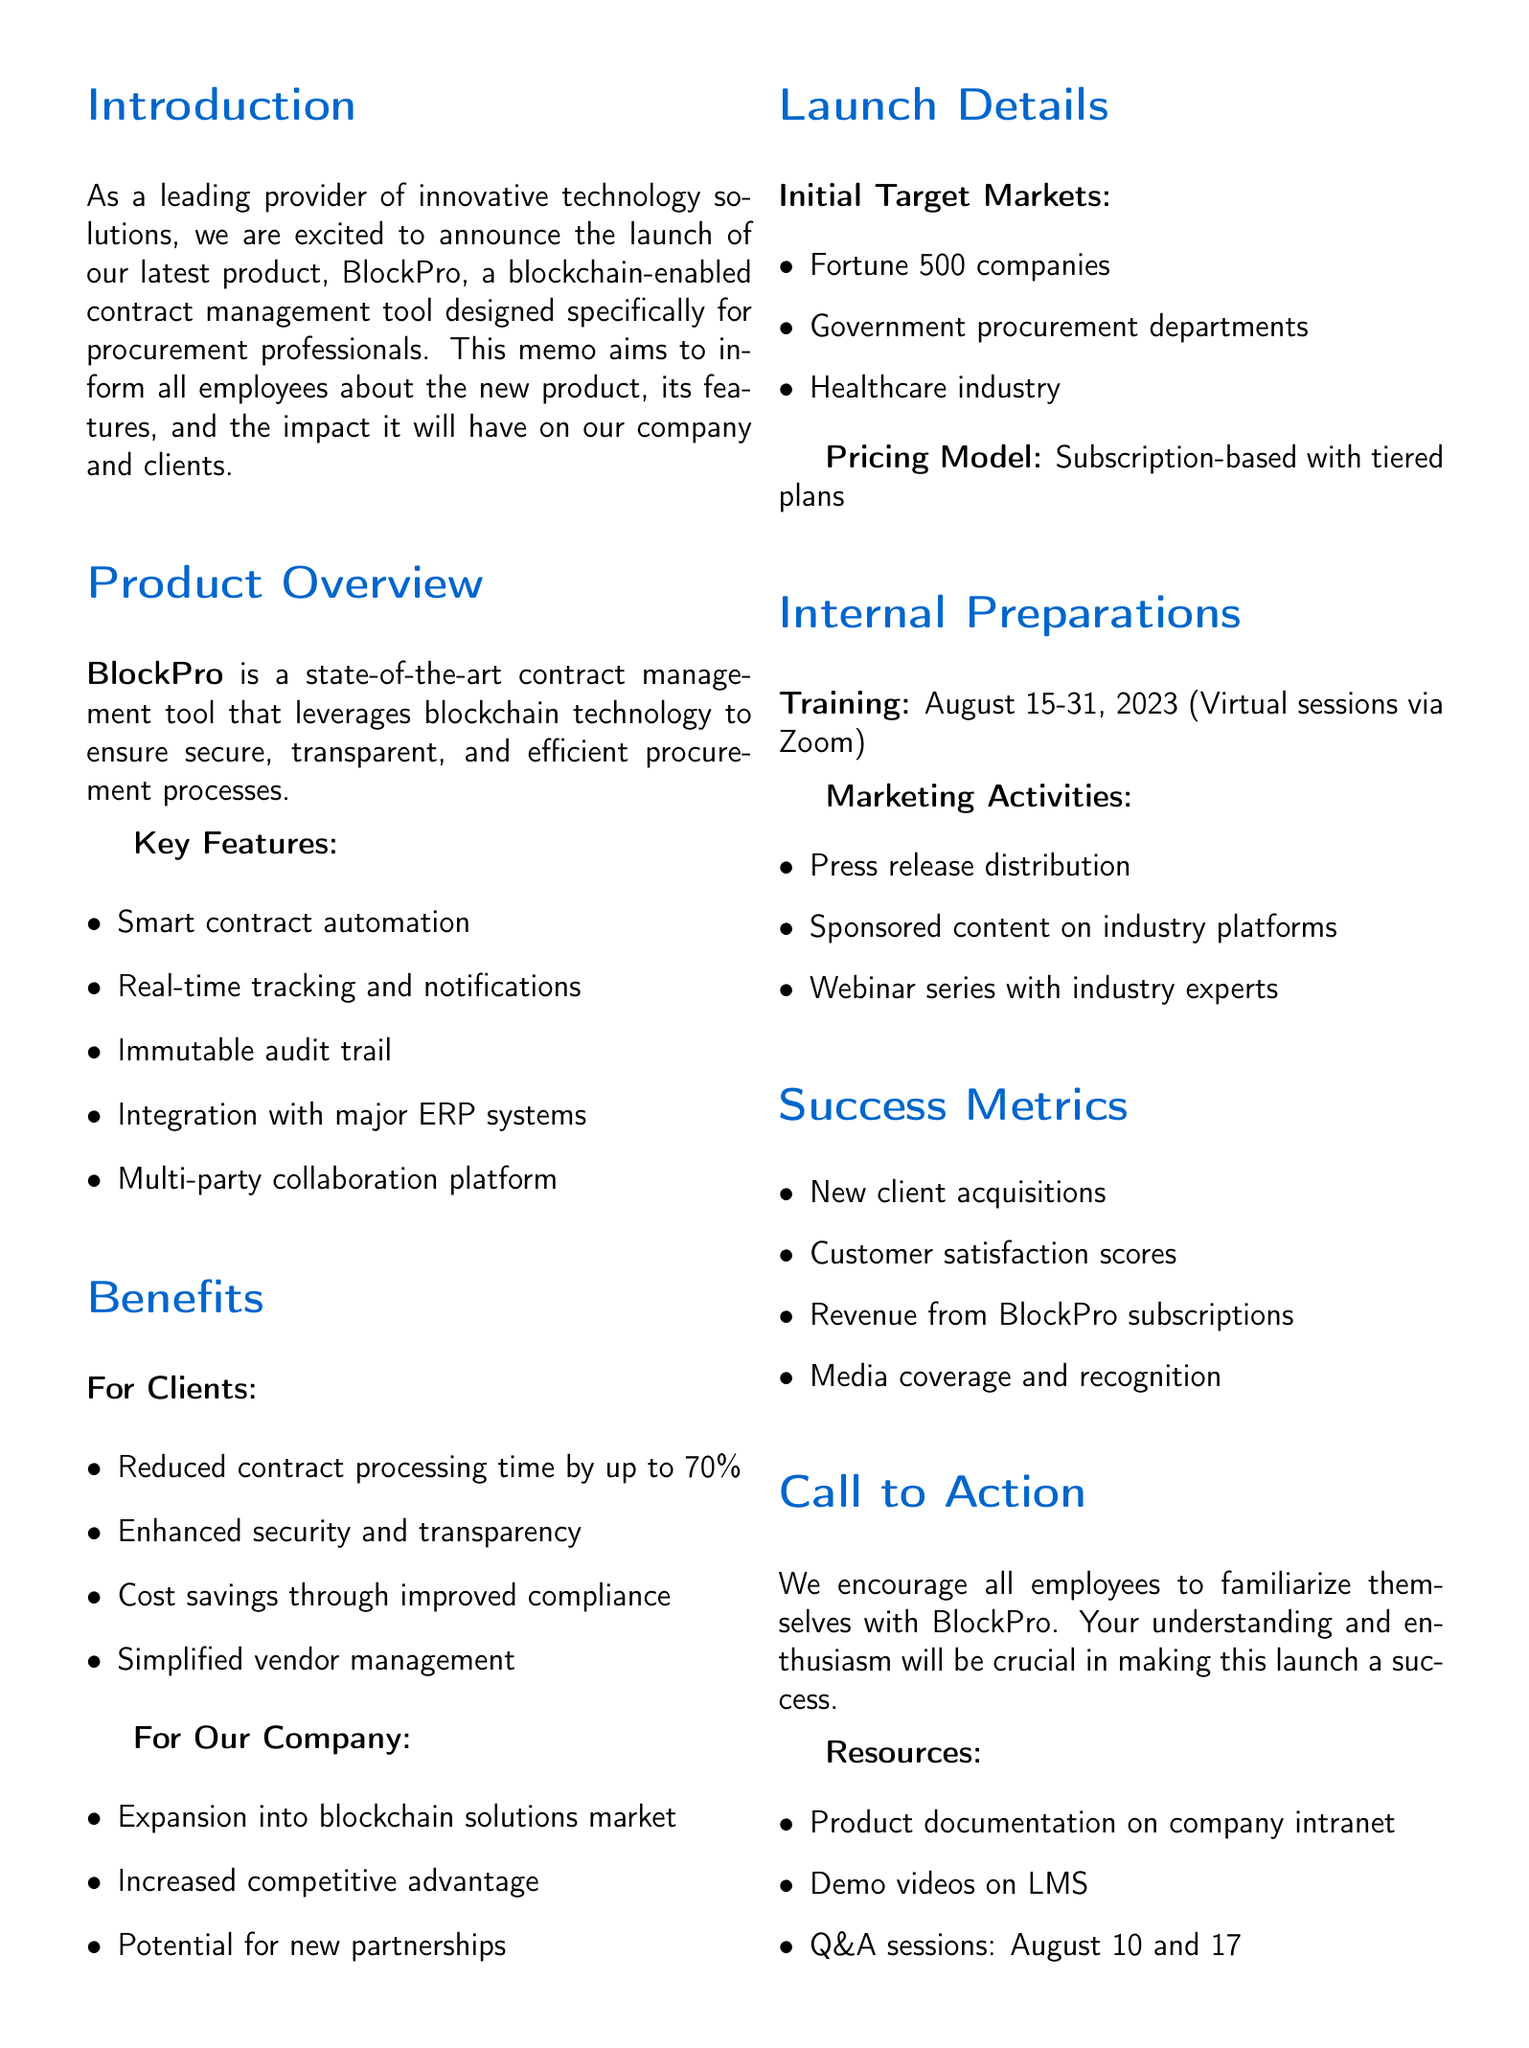What is the name of the new tool? The document explicitly introduces the tool as BlockPro, which is its name.
Answer: BlockPro What is the launch date of BlockPro? The memo states the specific launch date of the product, which is September 1, 2023.
Answer: September 1, 2023 What are the initial target markets for BlockPro? The document lists three initial target markets for BlockPro: Fortune 500 companies, government procurement departments, and the healthcare industry.
Answer: Fortune 500 companies, government procurement departments, healthcare industry What is the expected reduction in contract processing time for clients? The memo mentions that clients can expect a reduction in contract processing time by up to 70%.
Answer: 70% What are the key training dates for internal preparations? The document notes that training sessions for employees are scheduled from August 15 to August 31, 2023.
Answer: August 15-31, 2023 What type of pricing model does BlockPro use? The memo describes the pricing model as subscription-based with tiered plans tailored to organization size and needs.
Answer: Subscription-based with tiered plans What are the success metrics defined in the document? The memo lists multiple success metrics including new client acquisitions and customer satisfaction scores.
Answer: Number of new client acquisitions, customer satisfaction scores, revenue generated from BlockPro subscriptions, media coverage and industry recognition Who should employees contact for questions regarding BlockPro? The memo provides a contact email for employees to reach out to the BlockPro Launch Team for any questions or suggestions.
Answer: blockpro@ourcompany.com What is the main purpose of this memo? The memo mentions its specific purpose is to inform all employees about the new product, its features, and the impact it will have on the company and clients.
Answer: To inform all employees about the new product, its features, and the impact it will have on our company and clients 